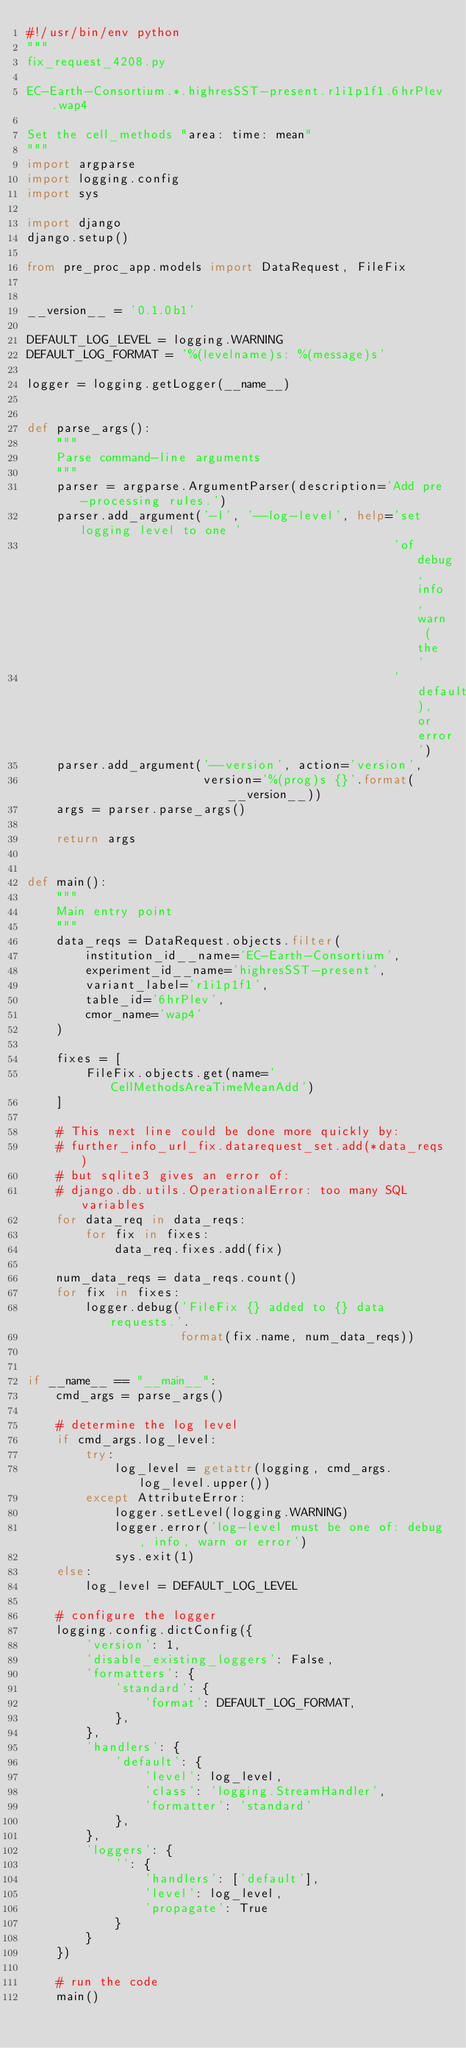Convert code to text. <code><loc_0><loc_0><loc_500><loc_500><_Python_>#!/usr/bin/env python
"""
fix_request_4208.py

EC-Earth-Consortium.*.highresSST-present.r1i1p1f1.6hrPlev.wap4

Set the cell_methods "area: time: mean"
"""
import argparse
import logging.config
import sys

import django
django.setup()

from pre_proc_app.models import DataRequest, FileFix


__version__ = '0.1.0b1'

DEFAULT_LOG_LEVEL = logging.WARNING
DEFAULT_LOG_FORMAT = '%(levelname)s: %(message)s'

logger = logging.getLogger(__name__)


def parse_args():
    """
    Parse command-line arguments
    """
    parser = argparse.ArgumentParser(description='Add pre-processing rules.')
    parser.add_argument('-l', '--log-level', help='set logging level to one '
                                                  'of debug, info, warn (the '
                                                  'default), or error')
    parser.add_argument('--version', action='version',
                        version='%(prog)s {}'.format(__version__))
    args = parser.parse_args()

    return args


def main():
    """
    Main entry point
    """
    data_reqs = DataRequest.objects.filter(
        institution_id__name='EC-Earth-Consortium',
        experiment_id__name='highresSST-present',
        variant_label='r1i1p1f1',
        table_id='6hrPlev',
        cmor_name='wap4'
    )

    fixes = [
        FileFix.objects.get(name='CellMethodsAreaTimeMeanAdd')
    ]

    # This next line could be done more quickly by:
    # further_info_url_fix.datarequest_set.add(*data_reqs)
    # but sqlite3 gives an error of:
    # django.db.utils.OperationalError: too many SQL variables
    for data_req in data_reqs:
        for fix in fixes:
            data_req.fixes.add(fix)

    num_data_reqs = data_reqs.count()
    for fix in fixes:
        logger.debug('FileFix {} added to {} data requests.'.
                     format(fix.name, num_data_reqs))


if __name__ == "__main__":
    cmd_args = parse_args()

    # determine the log level
    if cmd_args.log_level:
        try:
            log_level = getattr(logging, cmd_args.log_level.upper())
        except AttributeError:
            logger.setLevel(logging.WARNING)
            logger.error('log-level must be one of: debug, info, warn or error')
            sys.exit(1)
    else:
        log_level = DEFAULT_LOG_LEVEL

    # configure the logger
    logging.config.dictConfig({
        'version': 1,
        'disable_existing_loggers': False,
        'formatters': {
            'standard': {
                'format': DEFAULT_LOG_FORMAT,
            },
        },
        'handlers': {
            'default': {
                'level': log_level,
                'class': 'logging.StreamHandler',
                'formatter': 'standard'
            },
        },
        'loggers': {
            '': {
                'handlers': ['default'],
                'level': log_level,
                'propagate': True
            }
        }
    })

    # run the code
    main()
</code> 